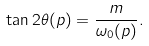<formula> <loc_0><loc_0><loc_500><loc_500>\tan 2 \theta ( p ) = \frac { m } { \omega _ { 0 } ( p ) } .</formula> 